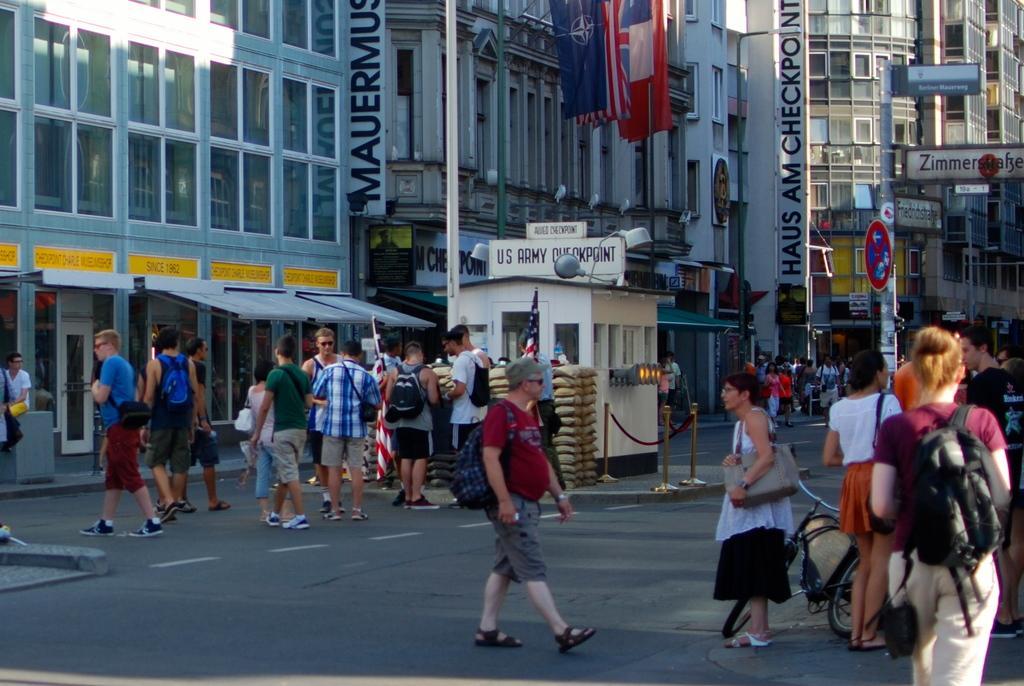How would you summarize this image in a sentence or two? In this image we can see the buildings. Here we can see the flag poles. Here we can see the hoardings on the side of the buildings. Here we can see a group of people walking on the road. Here we can see a bicycle on the road. Here we can see a few people carrying the bags on their back. 